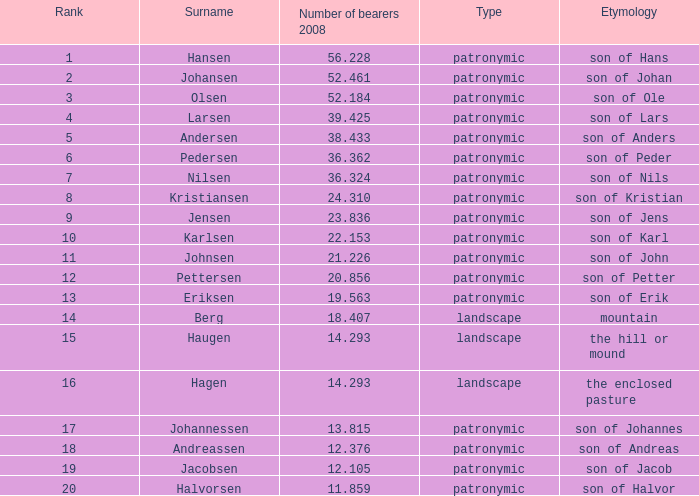What is the highest Number of Bearers 2008, when Surname is Hansen, and when Rank is less than 1? None. 